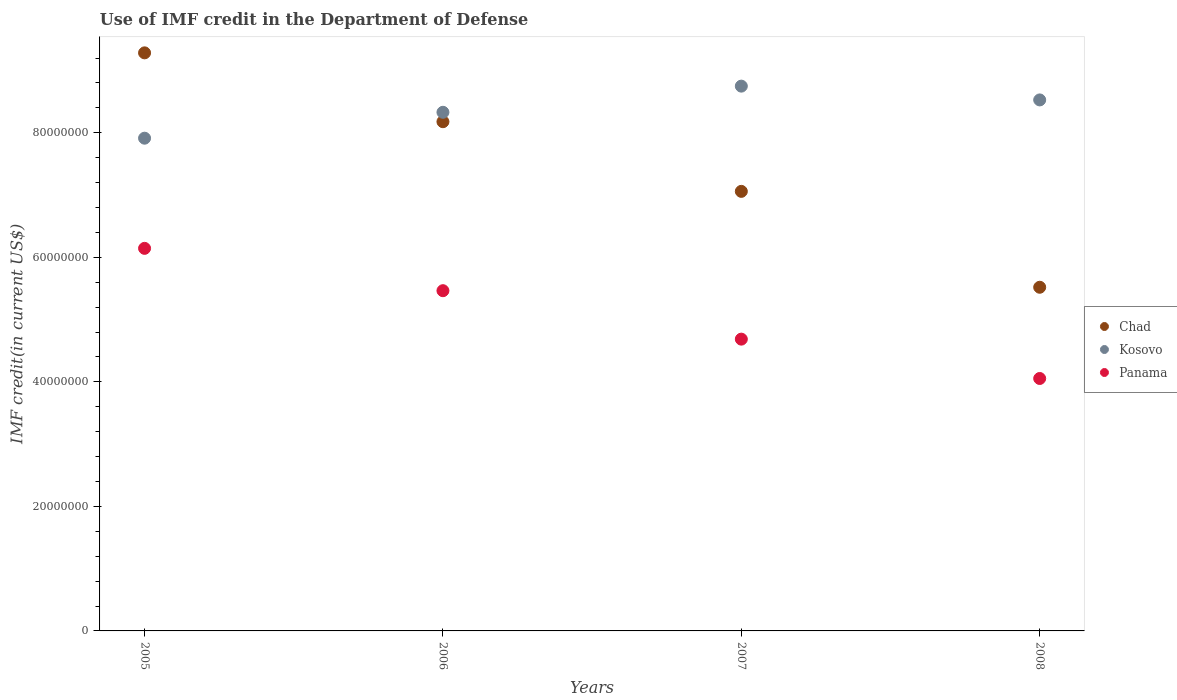Is the number of dotlines equal to the number of legend labels?
Provide a succinct answer. Yes. What is the IMF credit in the Department of Defense in Panama in 2005?
Your answer should be compact. 6.14e+07. Across all years, what is the maximum IMF credit in the Department of Defense in Panama?
Your answer should be compact. 6.14e+07. Across all years, what is the minimum IMF credit in the Department of Defense in Chad?
Provide a succinct answer. 5.52e+07. In which year was the IMF credit in the Department of Defense in Kosovo maximum?
Your answer should be very brief. 2007. What is the total IMF credit in the Department of Defense in Chad in the graph?
Make the answer very short. 3.00e+08. What is the difference between the IMF credit in the Department of Defense in Panama in 2006 and that in 2007?
Make the answer very short. 7.78e+06. What is the difference between the IMF credit in the Department of Defense in Chad in 2007 and the IMF credit in the Department of Defense in Panama in 2008?
Keep it short and to the point. 3.01e+07. What is the average IMF credit in the Department of Defense in Kosovo per year?
Give a very brief answer. 8.38e+07. In the year 2008, what is the difference between the IMF credit in the Department of Defense in Panama and IMF credit in the Department of Defense in Kosovo?
Make the answer very short. -4.47e+07. What is the ratio of the IMF credit in the Department of Defense in Panama in 2005 to that in 2008?
Your answer should be compact. 1.52. What is the difference between the highest and the second highest IMF credit in the Department of Defense in Chad?
Your answer should be very brief. 1.11e+07. What is the difference between the highest and the lowest IMF credit in the Department of Defense in Chad?
Your answer should be very brief. 3.76e+07. In how many years, is the IMF credit in the Department of Defense in Panama greater than the average IMF credit in the Department of Defense in Panama taken over all years?
Your answer should be compact. 2. Is the sum of the IMF credit in the Department of Defense in Panama in 2005 and 2008 greater than the maximum IMF credit in the Department of Defense in Kosovo across all years?
Ensure brevity in your answer.  Yes. Is it the case that in every year, the sum of the IMF credit in the Department of Defense in Kosovo and IMF credit in the Department of Defense in Panama  is greater than the IMF credit in the Department of Defense in Chad?
Keep it short and to the point. Yes. How many dotlines are there?
Give a very brief answer. 3. What is the difference between two consecutive major ticks on the Y-axis?
Your answer should be compact. 2.00e+07. Are the values on the major ticks of Y-axis written in scientific E-notation?
Make the answer very short. No. Where does the legend appear in the graph?
Offer a very short reply. Center right. How many legend labels are there?
Offer a very short reply. 3. How are the legend labels stacked?
Offer a very short reply. Vertical. What is the title of the graph?
Ensure brevity in your answer.  Use of IMF credit in the Department of Defense. What is the label or title of the Y-axis?
Keep it short and to the point. IMF credit(in current US$). What is the IMF credit(in current US$) of Chad in 2005?
Make the answer very short. 9.28e+07. What is the IMF credit(in current US$) of Kosovo in 2005?
Offer a terse response. 7.91e+07. What is the IMF credit(in current US$) in Panama in 2005?
Your answer should be compact. 6.14e+07. What is the IMF credit(in current US$) of Chad in 2006?
Provide a short and direct response. 8.18e+07. What is the IMF credit(in current US$) in Kosovo in 2006?
Provide a succinct answer. 8.33e+07. What is the IMF credit(in current US$) in Panama in 2006?
Ensure brevity in your answer.  5.46e+07. What is the IMF credit(in current US$) in Chad in 2007?
Your answer should be very brief. 7.06e+07. What is the IMF credit(in current US$) of Kosovo in 2007?
Your answer should be very brief. 8.75e+07. What is the IMF credit(in current US$) of Panama in 2007?
Ensure brevity in your answer.  4.69e+07. What is the IMF credit(in current US$) of Chad in 2008?
Offer a terse response. 5.52e+07. What is the IMF credit(in current US$) in Kosovo in 2008?
Make the answer very short. 8.53e+07. What is the IMF credit(in current US$) of Panama in 2008?
Make the answer very short. 4.05e+07. Across all years, what is the maximum IMF credit(in current US$) of Chad?
Offer a terse response. 9.28e+07. Across all years, what is the maximum IMF credit(in current US$) of Kosovo?
Ensure brevity in your answer.  8.75e+07. Across all years, what is the maximum IMF credit(in current US$) of Panama?
Offer a very short reply. 6.14e+07. Across all years, what is the minimum IMF credit(in current US$) of Chad?
Your answer should be compact. 5.52e+07. Across all years, what is the minimum IMF credit(in current US$) of Kosovo?
Offer a very short reply. 7.91e+07. Across all years, what is the minimum IMF credit(in current US$) of Panama?
Your answer should be very brief. 4.05e+07. What is the total IMF credit(in current US$) in Chad in the graph?
Your answer should be compact. 3.00e+08. What is the total IMF credit(in current US$) of Kosovo in the graph?
Keep it short and to the point. 3.35e+08. What is the total IMF credit(in current US$) of Panama in the graph?
Offer a very short reply. 2.03e+08. What is the difference between the IMF credit(in current US$) in Chad in 2005 and that in 2006?
Make the answer very short. 1.11e+07. What is the difference between the IMF credit(in current US$) of Kosovo in 2005 and that in 2006?
Give a very brief answer. -4.16e+06. What is the difference between the IMF credit(in current US$) of Panama in 2005 and that in 2006?
Provide a short and direct response. 6.80e+06. What is the difference between the IMF credit(in current US$) of Chad in 2005 and that in 2007?
Keep it short and to the point. 2.22e+07. What is the difference between the IMF credit(in current US$) in Kosovo in 2005 and that in 2007?
Your response must be concise. -8.36e+06. What is the difference between the IMF credit(in current US$) in Panama in 2005 and that in 2007?
Your response must be concise. 1.46e+07. What is the difference between the IMF credit(in current US$) in Chad in 2005 and that in 2008?
Your response must be concise. 3.76e+07. What is the difference between the IMF credit(in current US$) in Kosovo in 2005 and that in 2008?
Provide a short and direct response. -6.15e+06. What is the difference between the IMF credit(in current US$) of Panama in 2005 and that in 2008?
Your response must be concise. 2.09e+07. What is the difference between the IMF credit(in current US$) of Chad in 2006 and that in 2007?
Offer a very short reply. 1.12e+07. What is the difference between the IMF credit(in current US$) of Kosovo in 2006 and that in 2007?
Ensure brevity in your answer.  -4.20e+06. What is the difference between the IMF credit(in current US$) in Panama in 2006 and that in 2007?
Offer a very short reply. 7.78e+06. What is the difference between the IMF credit(in current US$) of Chad in 2006 and that in 2008?
Make the answer very short. 2.66e+07. What is the difference between the IMF credit(in current US$) of Kosovo in 2006 and that in 2008?
Your answer should be compact. -1.99e+06. What is the difference between the IMF credit(in current US$) of Panama in 2006 and that in 2008?
Provide a succinct answer. 1.41e+07. What is the difference between the IMF credit(in current US$) in Chad in 2007 and that in 2008?
Ensure brevity in your answer.  1.54e+07. What is the difference between the IMF credit(in current US$) of Kosovo in 2007 and that in 2008?
Offer a very short reply. 2.21e+06. What is the difference between the IMF credit(in current US$) in Panama in 2007 and that in 2008?
Ensure brevity in your answer.  6.32e+06. What is the difference between the IMF credit(in current US$) of Chad in 2005 and the IMF credit(in current US$) of Kosovo in 2006?
Provide a succinct answer. 9.54e+06. What is the difference between the IMF credit(in current US$) in Chad in 2005 and the IMF credit(in current US$) in Panama in 2006?
Keep it short and to the point. 3.82e+07. What is the difference between the IMF credit(in current US$) of Kosovo in 2005 and the IMF credit(in current US$) of Panama in 2006?
Provide a short and direct response. 2.45e+07. What is the difference between the IMF credit(in current US$) in Chad in 2005 and the IMF credit(in current US$) in Kosovo in 2007?
Keep it short and to the point. 5.34e+06. What is the difference between the IMF credit(in current US$) of Chad in 2005 and the IMF credit(in current US$) of Panama in 2007?
Provide a succinct answer. 4.60e+07. What is the difference between the IMF credit(in current US$) in Kosovo in 2005 and the IMF credit(in current US$) in Panama in 2007?
Offer a very short reply. 3.23e+07. What is the difference between the IMF credit(in current US$) of Chad in 2005 and the IMF credit(in current US$) of Kosovo in 2008?
Your answer should be compact. 7.56e+06. What is the difference between the IMF credit(in current US$) of Chad in 2005 and the IMF credit(in current US$) of Panama in 2008?
Your answer should be very brief. 5.23e+07. What is the difference between the IMF credit(in current US$) in Kosovo in 2005 and the IMF credit(in current US$) in Panama in 2008?
Your response must be concise. 3.86e+07. What is the difference between the IMF credit(in current US$) of Chad in 2006 and the IMF credit(in current US$) of Kosovo in 2007?
Your response must be concise. -5.71e+06. What is the difference between the IMF credit(in current US$) of Chad in 2006 and the IMF credit(in current US$) of Panama in 2007?
Provide a succinct answer. 3.49e+07. What is the difference between the IMF credit(in current US$) in Kosovo in 2006 and the IMF credit(in current US$) in Panama in 2007?
Your answer should be very brief. 3.64e+07. What is the difference between the IMF credit(in current US$) of Chad in 2006 and the IMF credit(in current US$) of Kosovo in 2008?
Your answer should be very brief. -3.50e+06. What is the difference between the IMF credit(in current US$) in Chad in 2006 and the IMF credit(in current US$) in Panama in 2008?
Offer a terse response. 4.12e+07. What is the difference between the IMF credit(in current US$) of Kosovo in 2006 and the IMF credit(in current US$) of Panama in 2008?
Your answer should be compact. 4.28e+07. What is the difference between the IMF credit(in current US$) of Chad in 2007 and the IMF credit(in current US$) of Kosovo in 2008?
Provide a succinct answer. -1.47e+07. What is the difference between the IMF credit(in current US$) of Chad in 2007 and the IMF credit(in current US$) of Panama in 2008?
Provide a short and direct response. 3.01e+07. What is the difference between the IMF credit(in current US$) of Kosovo in 2007 and the IMF credit(in current US$) of Panama in 2008?
Offer a terse response. 4.70e+07. What is the average IMF credit(in current US$) of Chad per year?
Keep it short and to the point. 7.51e+07. What is the average IMF credit(in current US$) of Kosovo per year?
Your answer should be compact. 8.38e+07. What is the average IMF credit(in current US$) in Panama per year?
Make the answer very short. 5.09e+07. In the year 2005, what is the difference between the IMF credit(in current US$) of Chad and IMF credit(in current US$) of Kosovo?
Give a very brief answer. 1.37e+07. In the year 2005, what is the difference between the IMF credit(in current US$) in Chad and IMF credit(in current US$) in Panama?
Ensure brevity in your answer.  3.14e+07. In the year 2005, what is the difference between the IMF credit(in current US$) of Kosovo and IMF credit(in current US$) of Panama?
Give a very brief answer. 1.77e+07. In the year 2006, what is the difference between the IMF credit(in current US$) in Chad and IMF credit(in current US$) in Kosovo?
Make the answer very short. -1.51e+06. In the year 2006, what is the difference between the IMF credit(in current US$) in Chad and IMF credit(in current US$) in Panama?
Offer a terse response. 2.71e+07. In the year 2006, what is the difference between the IMF credit(in current US$) in Kosovo and IMF credit(in current US$) in Panama?
Your answer should be compact. 2.87e+07. In the year 2007, what is the difference between the IMF credit(in current US$) of Chad and IMF credit(in current US$) of Kosovo?
Your response must be concise. -1.69e+07. In the year 2007, what is the difference between the IMF credit(in current US$) of Chad and IMF credit(in current US$) of Panama?
Keep it short and to the point. 2.37e+07. In the year 2007, what is the difference between the IMF credit(in current US$) of Kosovo and IMF credit(in current US$) of Panama?
Make the answer very short. 4.06e+07. In the year 2008, what is the difference between the IMF credit(in current US$) of Chad and IMF credit(in current US$) of Kosovo?
Offer a terse response. -3.01e+07. In the year 2008, what is the difference between the IMF credit(in current US$) of Chad and IMF credit(in current US$) of Panama?
Offer a terse response. 1.47e+07. In the year 2008, what is the difference between the IMF credit(in current US$) in Kosovo and IMF credit(in current US$) in Panama?
Your answer should be compact. 4.47e+07. What is the ratio of the IMF credit(in current US$) in Chad in 2005 to that in 2006?
Make the answer very short. 1.14. What is the ratio of the IMF credit(in current US$) of Kosovo in 2005 to that in 2006?
Offer a terse response. 0.95. What is the ratio of the IMF credit(in current US$) of Panama in 2005 to that in 2006?
Make the answer very short. 1.12. What is the ratio of the IMF credit(in current US$) of Chad in 2005 to that in 2007?
Your answer should be very brief. 1.32. What is the ratio of the IMF credit(in current US$) of Kosovo in 2005 to that in 2007?
Your answer should be compact. 0.9. What is the ratio of the IMF credit(in current US$) of Panama in 2005 to that in 2007?
Provide a short and direct response. 1.31. What is the ratio of the IMF credit(in current US$) in Chad in 2005 to that in 2008?
Make the answer very short. 1.68. What is the ratio of the IMF credit(in current US$) of Kosovo in 2005 to that in 2008?
Offer a very short reply. 0.93. What is the ratio of the IMF credit(in current US$) in Panama in 2005 to that in 2008?
Offer a very short reply. 1.52. What is the ratio of the IMF credit(in current US$) in Chad in 2006 to that in 2007?
Give a very brief answer. 1.16. What is the ratio of the IMF credit(in current US$) in Panama in 2006 to that in 2007?
Offer a very short reply. 1.17. What is the ratio of the IMF credit(in current US$) in Chad in 2006 to that in 2008?
Keep it short and to the point. 1.48. What is the ratio of the IMF credit(in current US$) of Kosovo in 2006 to that in 2008?
Provide a short and direct response. 0.98. What is the ratio of the IMF credit(in current US$) of Panama in 2006 to that in 2008?
Give a very brief answer. 1.35. What is the ratio of the IMF credit(in current US$) in Chad in 2007 to that in 2008?
Your response must be concise. 1.28. What is the ratio of the IMF credit(in current US$) in Panama in 2007 to that in 2008?
Your answer should be very brief. 1.16. What is the difference between the highest and the second highest IMF credit(in current US$) in Chad?
Your answer should be very brief. 1.11e+07. What is the difference between the highest and the second highest IMF credit(in current US$) of Kosovo?
Provide a succinct answer. 2.21e+06. What is the difference between the highest and the second highest IMF credit(in current US$) of Panama?
Offer a very short reply. 6.80e+06. What is the difference between the highest and the lowest IMF credit(in current US$) in Chad?
Your answer should be very brief. 3.76e+07. What is the difference between the highest and the lowest IMF credit(in current US$) of Kosovo?
Provide a succinct answer. 8.36e+06. What is the difference between the highest and the lowest IMF credit(in current US$) in Panama?
Your response must be concise. 2.09e+07. 